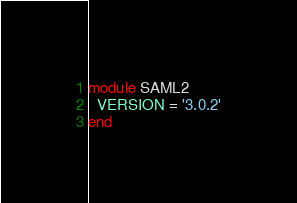<code> <loc_0><loc_0><loc_500><loc_500><_Ruby_>module SAML2
  VERSION = '3.0.2'
end
</code> 